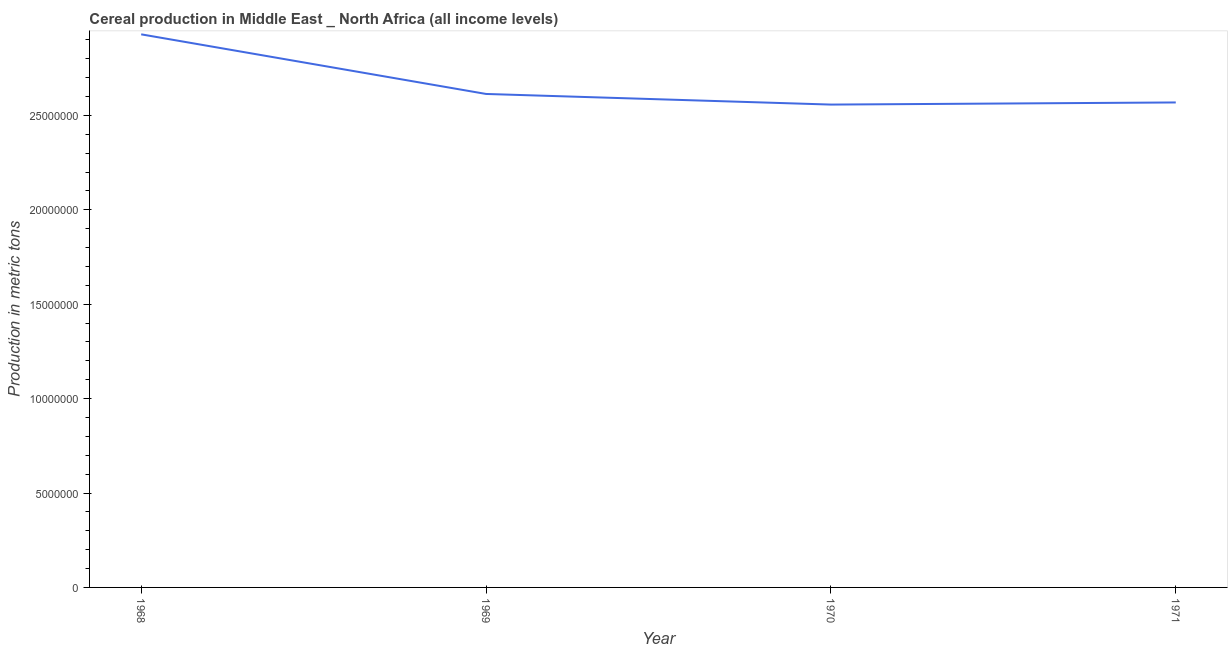What is the cereal production in 1969?
Offer a terse response. 2.61e+07. Across all years, what is the maximum cereal production?
Give a very brief answer. 2.93e+07. Across all years, what is the minimum cereal production?
Ensure brevity in your answer.  2.56e+07. In which year was the cereal production maximum?
Make the answer very short. 1968. In which year was the cereal production minimum?
Your response must be concise. 1970. What is the sum of the cereal production?
Give a very brief answer. 1.07e+08. What is the difference between the cereal production in 1968 and 1969?
Give a very brief answer. 3.16e+06. What is the average cereal production per year?
Keep it short and to the point. 2.67e+07. What is the median cereal production?
Make the answer very short. 2.59e+07. What is the ratio of the cereal production in 1968 to that in 1969?
Your answer should be very brief. 1.12. What is the difference between the highest and the second highest cereal production?
Your response must be concise. 3.16e+06. Is the sum of the cereal production in 1969 and 1971 greater than the maximum cereal production across all years?
Your response must be concise. Yes. What is the difference between the highest and the lowest cereal production?
Your answer should be compact. 3.72e+06. In how many years, is the cereal production greater than the average cereal production taken over all years?
Provide a succinct answer. 1. Does the cereal production monotonically increase over the years?
Your answer should be compact. No. How many lines are there?
Provide a short and direct response. 1. How many years are there in the graph?
Ensure brevity in your answer.  4. What is the title of the graph?
Your answer should be very brief. Cereal production in Middle East _ North Africa (all income levels). What is the label or title of the Y-axis?
Offer a very short reply. Production in metric tons. What is the Production in metric tons in 1968?
Offer a very short reply. 2.93e+07. What is the Production in metric tons in 1969?
Your answer should be very brief. 2.61e+07. What is the Production in metric tons in 1970?
Make the answer very short. 2.56e+07. What is the Production in metric tons in 1971?
Give a very brief answer. 2.57e+07. What is the difference between the Production in metric tons in 1968 and 1969?
Your response must be concise. 3.16e+06. What is the difference between the Production in metric tons in 1968 and 1970?
Ensure brevity in your answer.  3.72e+06. What is the difference between the Production in metric tons in 1968 and 1971?
Your answer should be very brief. 3.61e+06. What is the difference between the Production in metric tons in 1969 and 1970?
Provide a succinct answer. 5.62e+05. What is the difference between the Production in metric tons in 1969 and 1971?
Provide a short and direct response. 4.50e+05. What is the difference between the Production in metric tons in 1970 and 1971?
Your answer should be very brief. -1.12e+05. What is the ratio of the Production in metric tons in 1968 to that in 1969?
Provide a short and direct response. 1.12. What is the ratio of the Production in metric tons in 1968 to that in 1970?
Your answer should be very brief. 1.15. What is the ratio of the Production in metric tons in 1968 to that in 1971?
Your response must be concise. 1.14. What is the ratio of the Production in metric tons in 1970 to that in 1971?
Give a very brief answer. 1. 